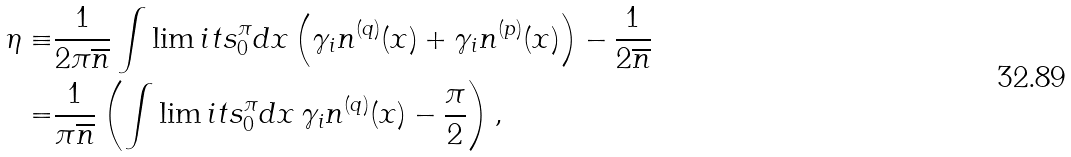Convert formula to latex. <formula><loc_0><loc_0><loc_500><loc_500>\eta \equiv & \frac { 1 } { 2 \pi \overline { n } } \int \lim i t s _ { 0 } ^ { \pi } { d x \left ( \gamma _ { i } n ^ { ( q ) } ( x ) + \gamma _ { i } n ^ { ( p ) } ( x ) \right ) } - \frac { 1 } { 2 \overline { n } } \\ = & \frac { 1 } { \pi \overline { n } } \left ( \int \lim i t s _ { 0 } ^ { \pi } { d x \, \gamma _ { i } n ^ { ( q ) } ( x ) } - \frac { \pi } { 2 } \right ) ,</formula> 